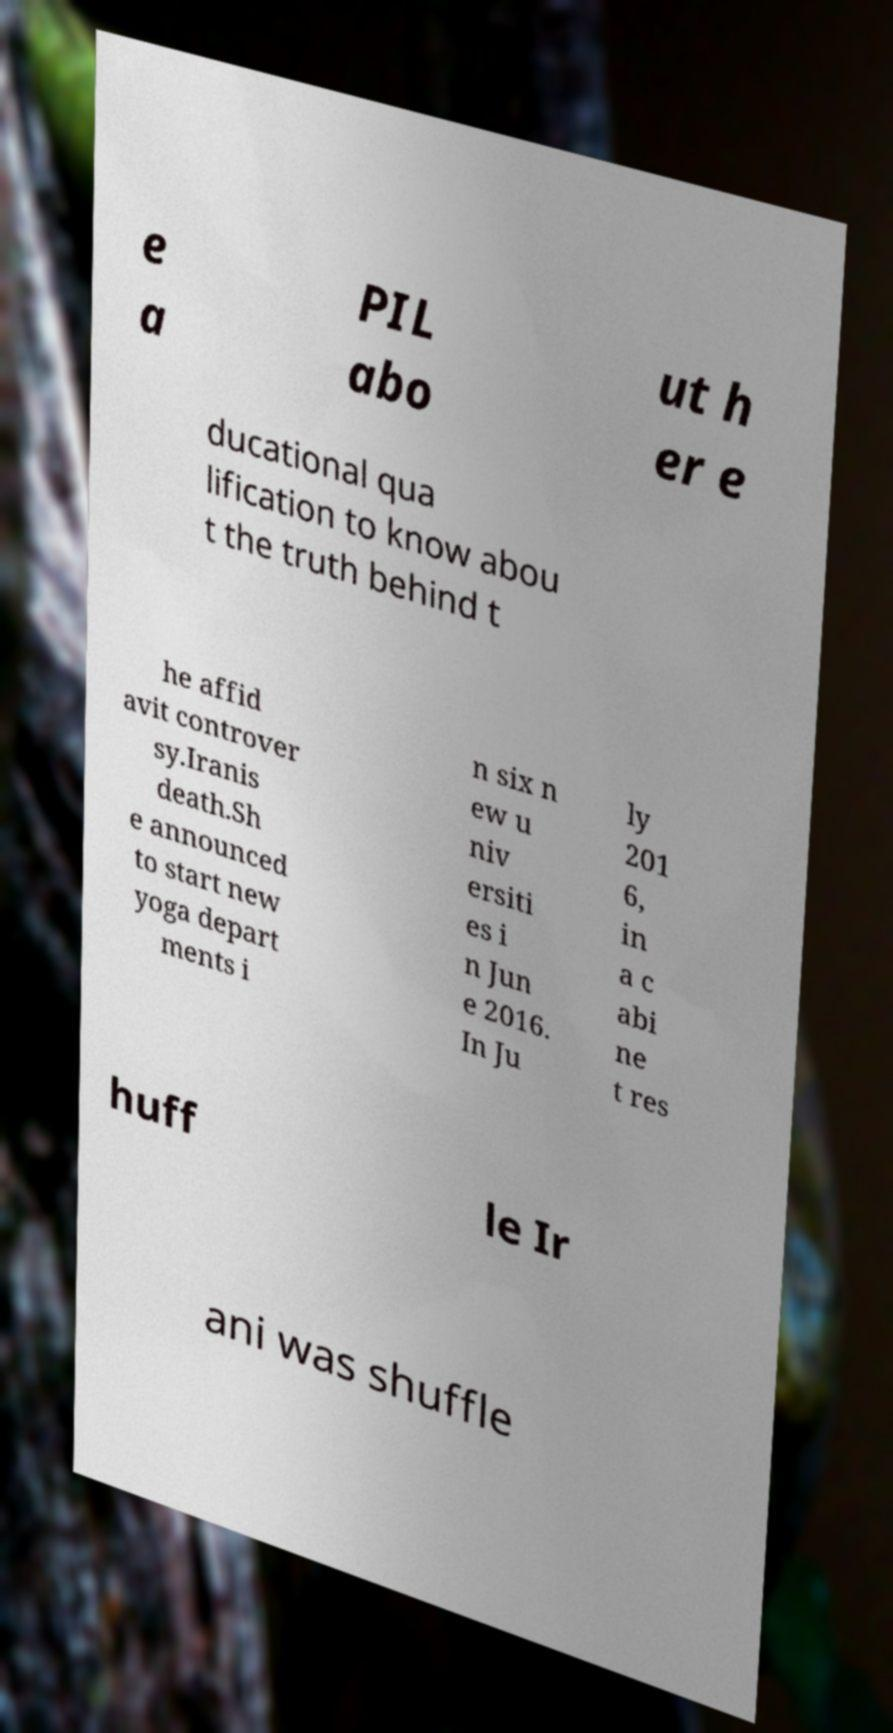What messages or text are displayed in this image? I need them in a readable, typed format. e a PIL abo ut h er e ducational qua lification to know abou t the truth behind t he affid avit controver sy.Iranis death.Sh e announced to start new yoga depart ments i n six n ew u niv ersiti es i n Jun e 2016. In Ju ly 201 6, in a c abi ne t res huff le Ir ani was shuffle 